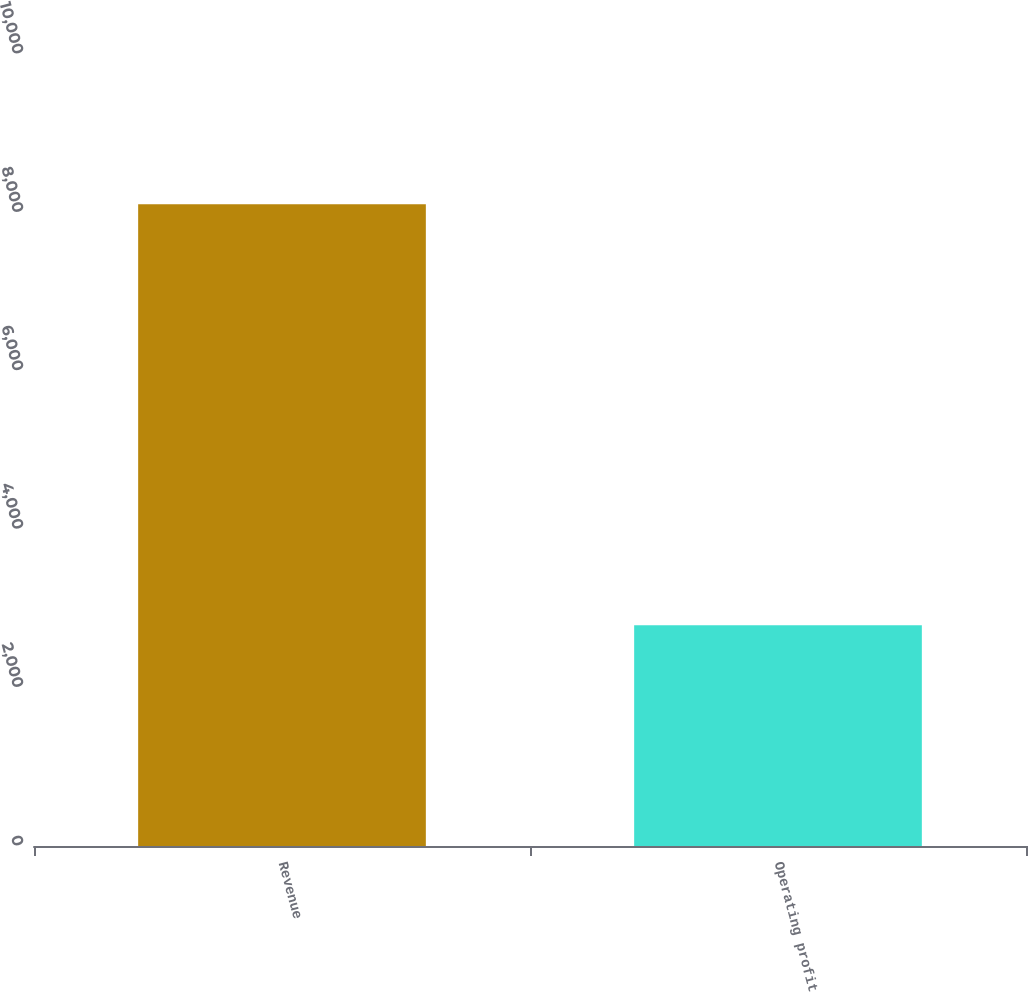Convert chart to OTSL. <chart><loc_0><loc_0><loc_500><loc_500><bar_chart><fcel>Revenue<fcel>Operating profit<nl><fcel>8104<fcel>2786<nl></chart> 